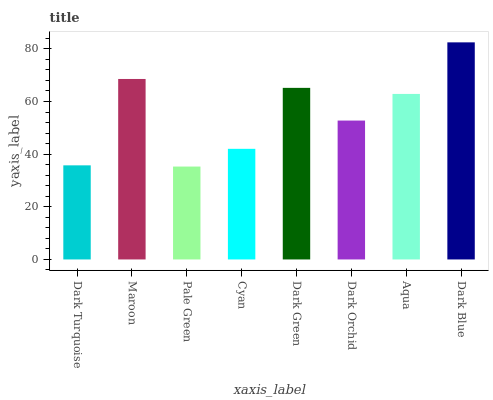Is Pale Green the minimum?
Answer yes or no. Yes. Is Dark Blue the maximum?
Answer yes or no. Yes. Is Maroon the minimum?
Answer yes or no. No. Is Maroon the maximum?
Answer yes or no. No. Is Maroon greater than Dark Turquoise?
Answer yes or no. Yes. Is Dark Turquoise less than Maroon?
Answer yes or no. Yes. Is Dark Turquoise greater than Maroon?
Answer yes or no. No. Is Maroon less than Dark Turquoise?
Answer yes or no. No. Is Aqua the high median?
Answer yes or no. Yes. Is Dark Orchid the low median?
Answer yes or no. Yes. Is Pale Green the high median?
Answer yes or no. No. Is Dark Green the low median?
Answer yes or no. No. 